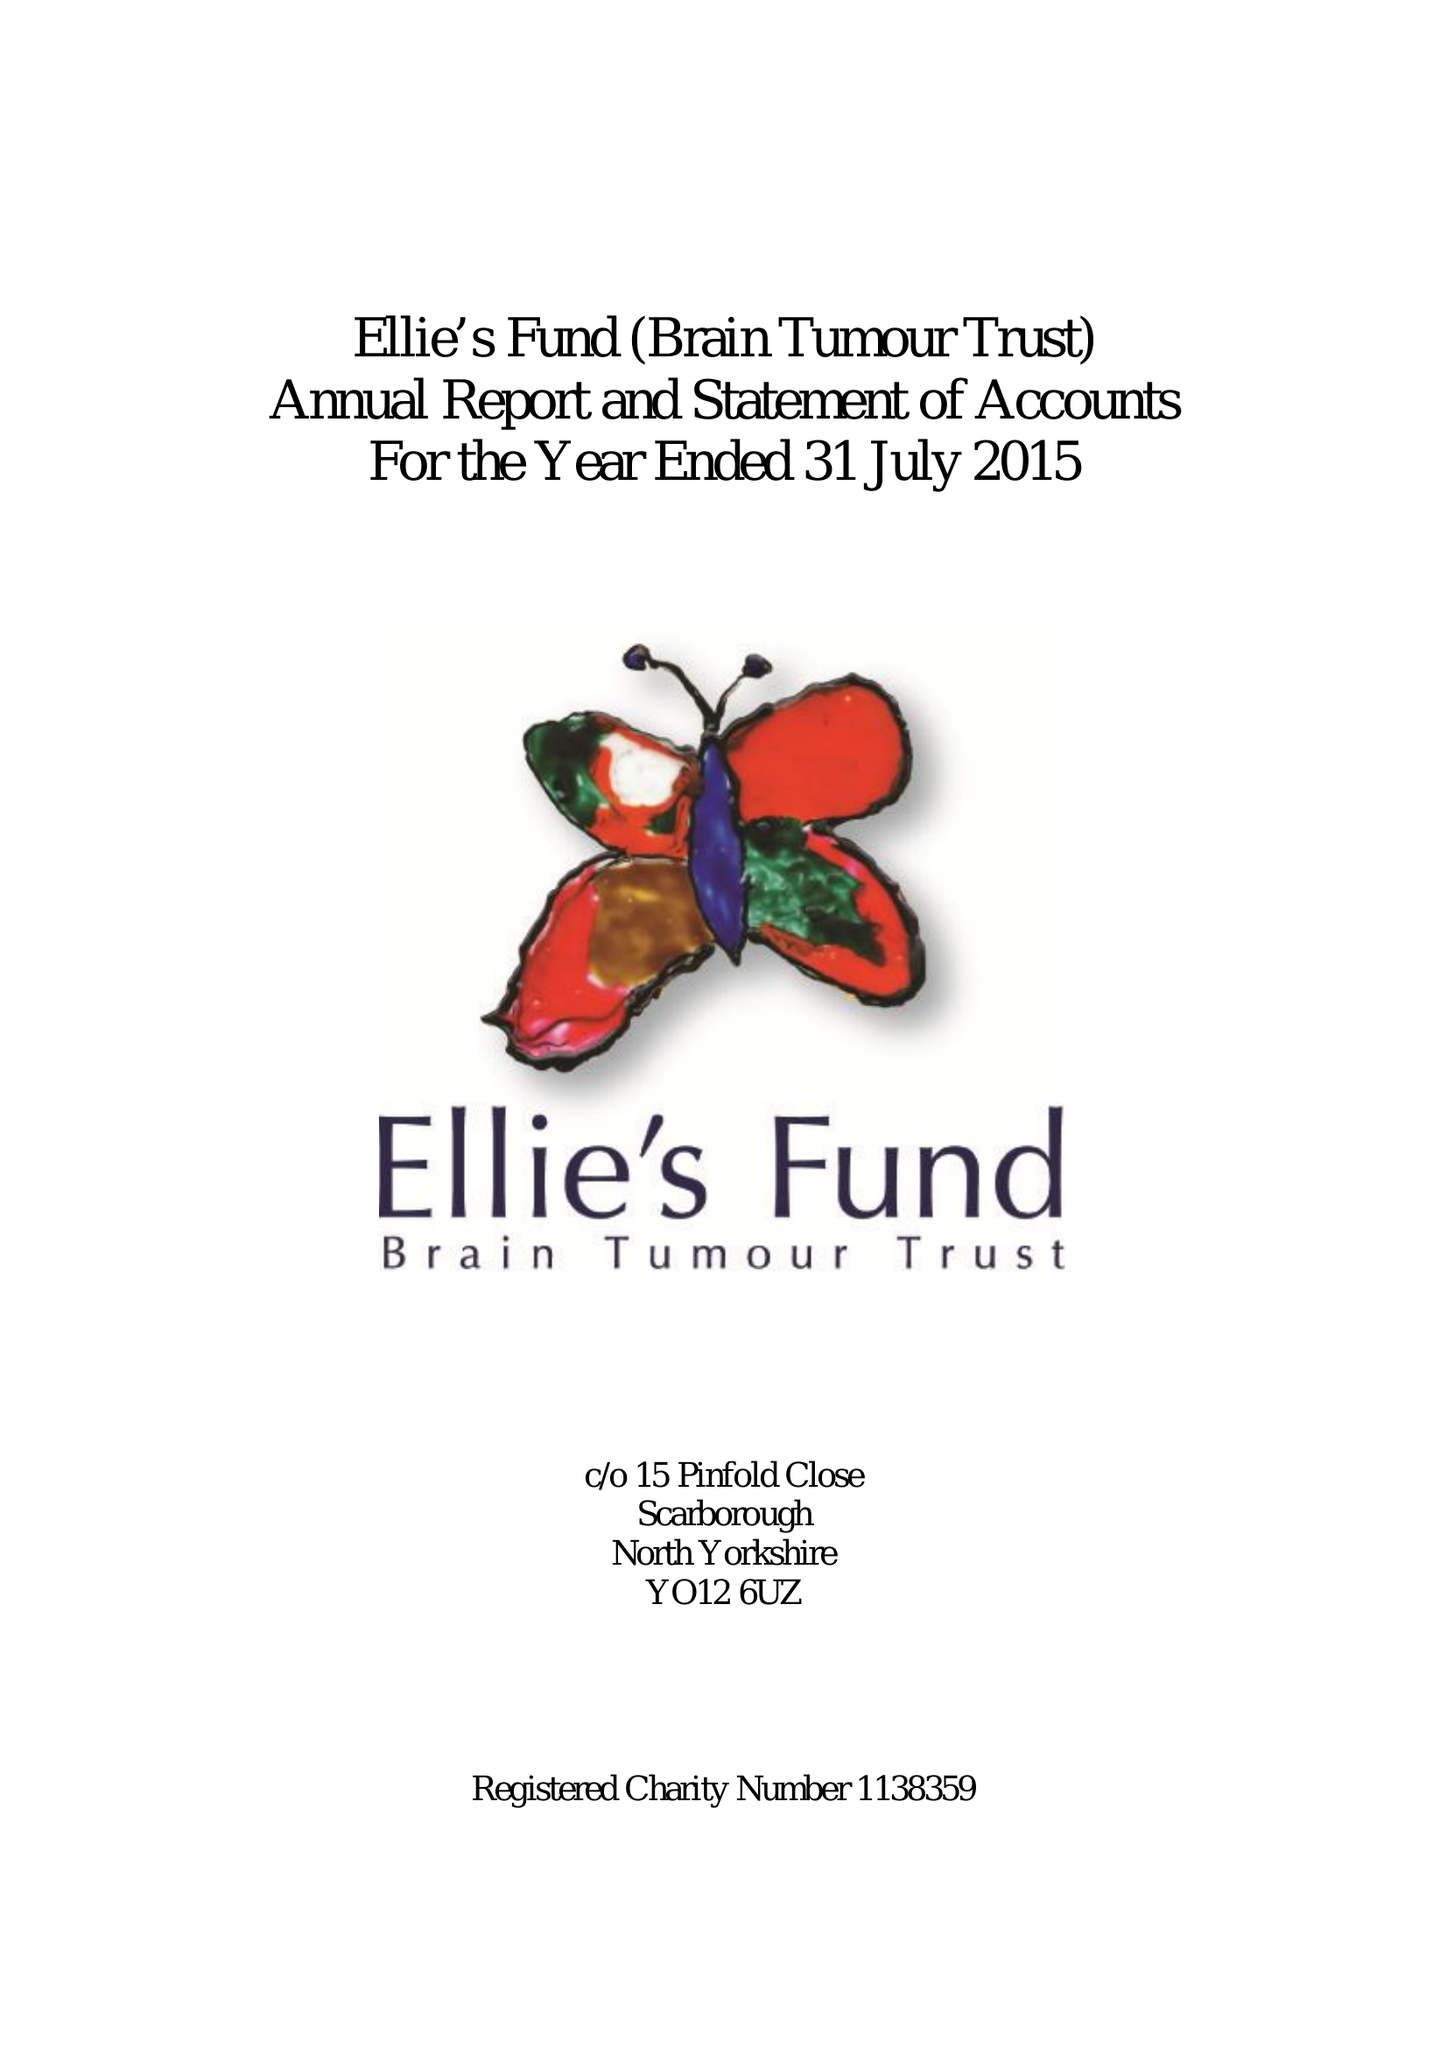What is the value for the address__post_town?
Answer the question using a single word or phrase. None 